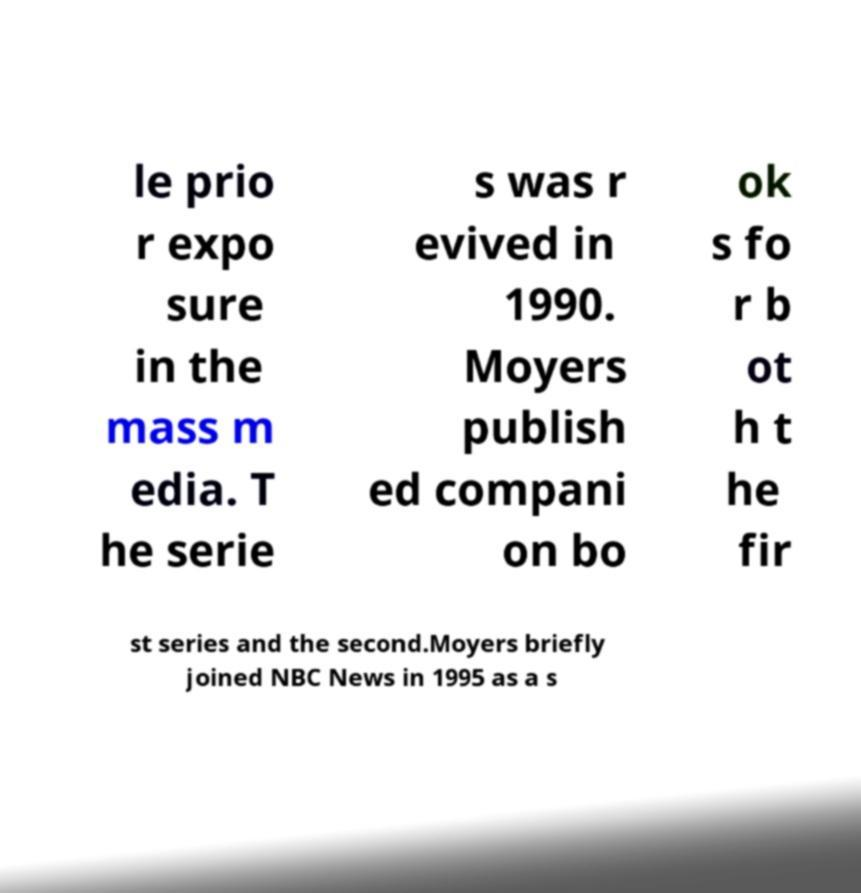Could you extract and type out the text from this image? le prio r expo sure in the mass m edia. T he serie s was r evived in 1990. Moyers publish ed compani on bo ok s fo r b ot h t he fir st series and the second.Moyers briefly joined NBC News in 1995 as a s 